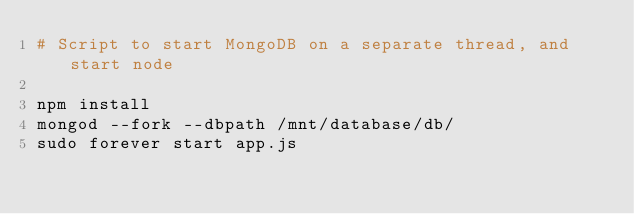<code> <loc_0><loc_0><loc_500><loc_500><_Bash_># Script to start MongoDB on a separate thread, and start node

npm install
mongod --fork --dbpath /mnt/database/db/
sudo forever start app.js</code> 